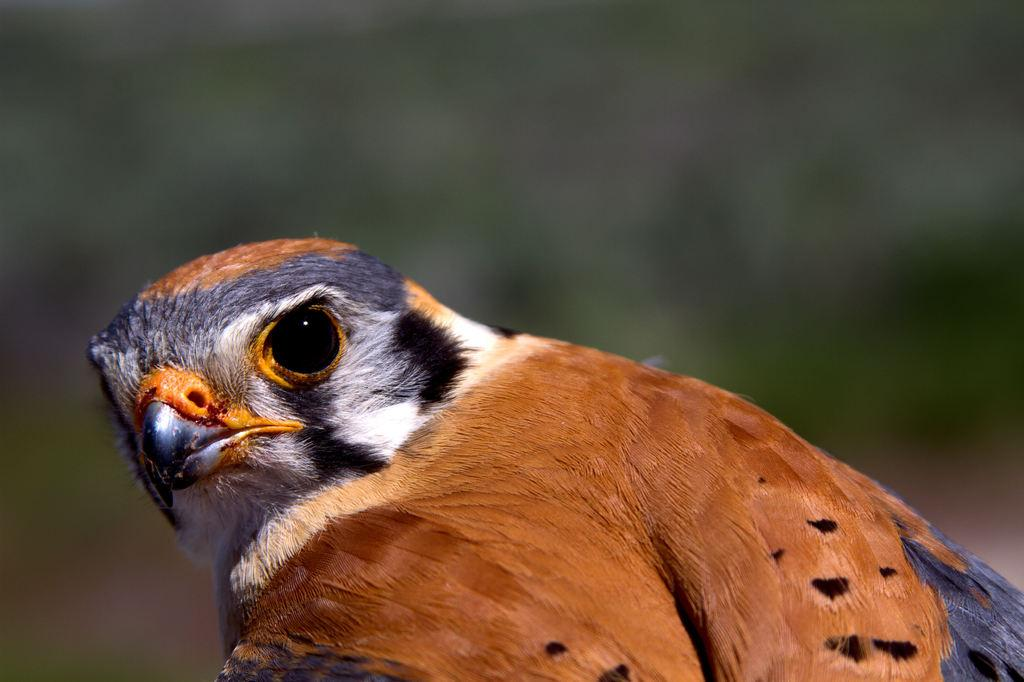What type of animal is present in the image? There is a bird in the image. Can you describe the colors of the bird? The bird has black, grey, white, and brown colors. What type of lift is used by the bird in the image? There is no lift present in the image, as it features a bird with various colors. What size is the spoon that the bird is holding in the image? There is no spoon present in the image, as it only features a bird with different colors. 